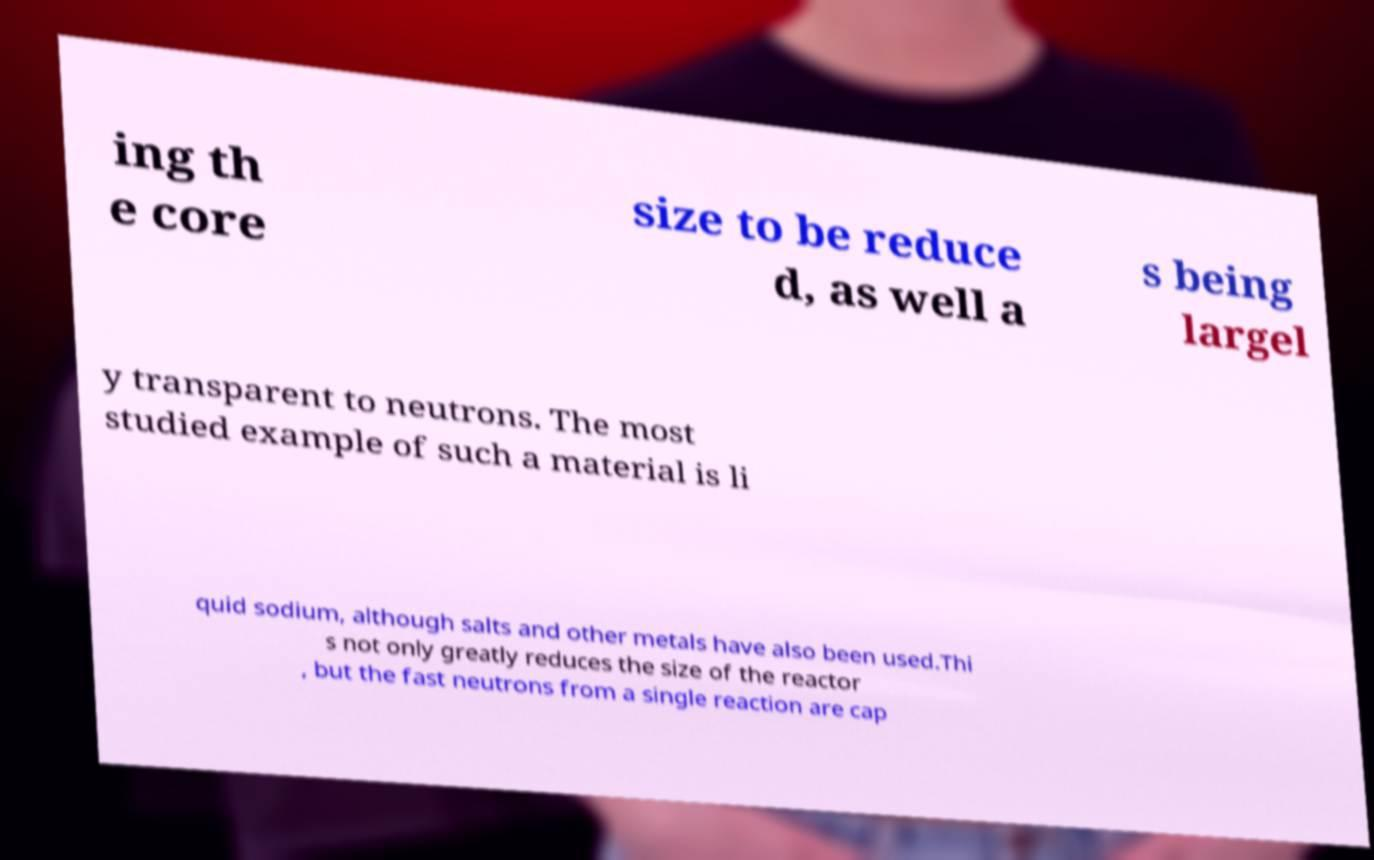Could you assist in decoding the text presented in this image and type it out clearly? ing th e core size to be reduce d, as well a s being largel y transparent to neutrons. The most studied example of such a material is li quid sodium, although salts and other metals have also been used.Thi s not only greatly reduces the size of the reactor , but the fast neutrons from a single reaction are cap 